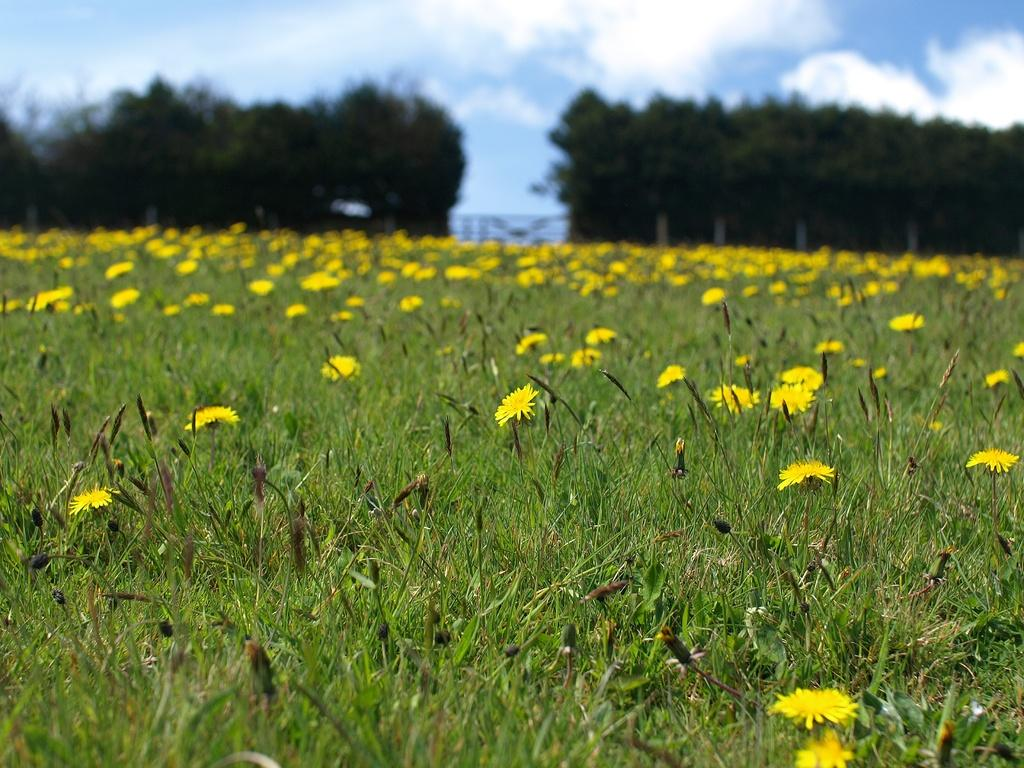What type of plants can be seen on the grassland in the image? There are yellow color flower plants on the grassland. What other natural elements can be seen in the background of the image? Trees are present on either side in the background. What is visible in the sky in the image? The sky is visible with clouds. What decision did the band make regarding their next performance in the image? There is no band or decision-making process present in the image; it features yellow flower plants, trees, and clouds. 